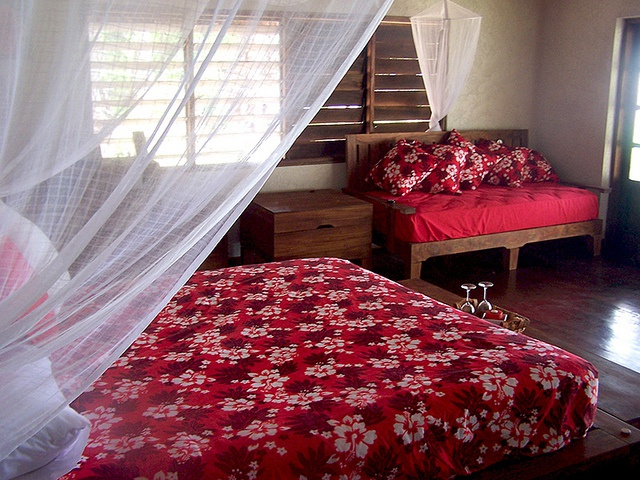Describe the objects in this image and their specific colors. I can see bed in darkgray, maroon, brown, and black tones, couch in darkgray, maroon, black, and brown tones, wine glass in darkgray, black, white, maroon, and gray tones, and wine glass in darkgray, black, white, maroon, and brown tones in this image. 